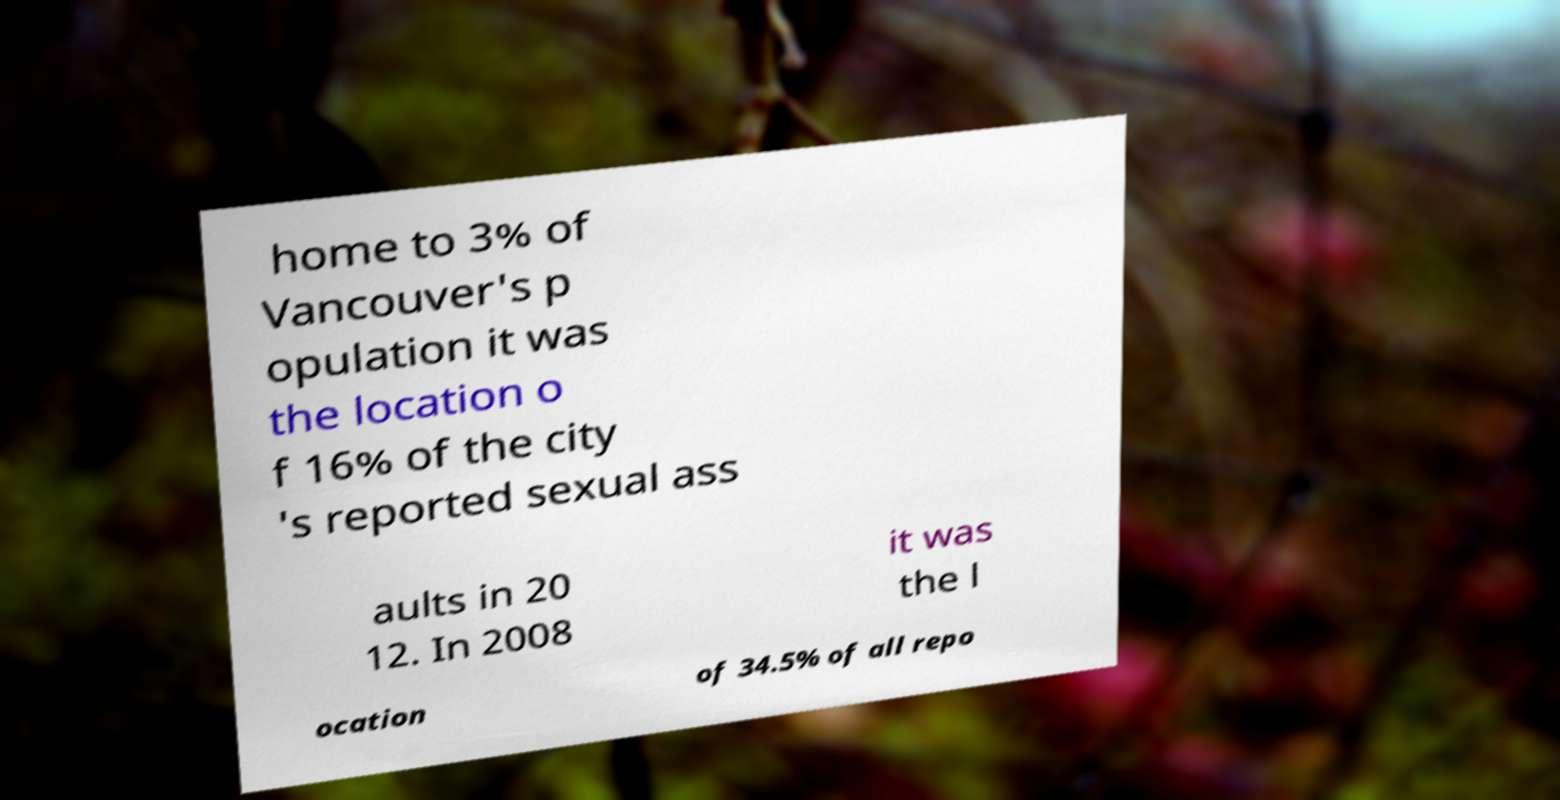I need the written content from this picture converted into text. Can you do that? home to 3% of Vancouver's p opulation it was the location o f 16% of the city 's reported sexual ass aults in 20 12. In 2008 it was the l ocation of 34.5% of all repo 